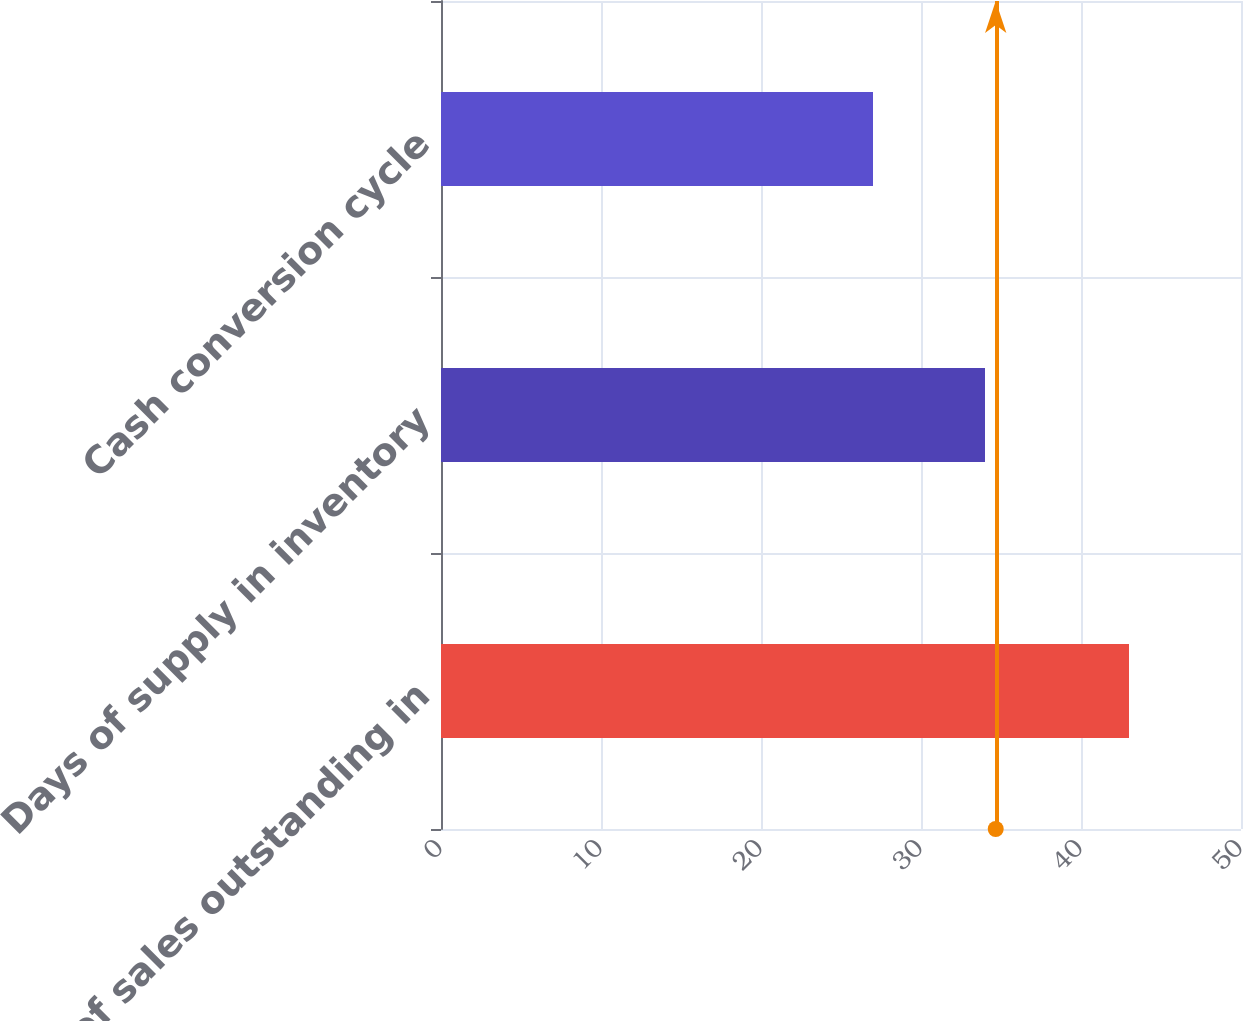<chart> <loc_0><loc_0><loc_500><loc_500><bar_chart><fcel>Days of sales outstanding in<fcel>Days of supply in inventory<fcel>Cash conversion cycle<nl><fcel>43<fcel>34<fcel>27<nl></chart> 